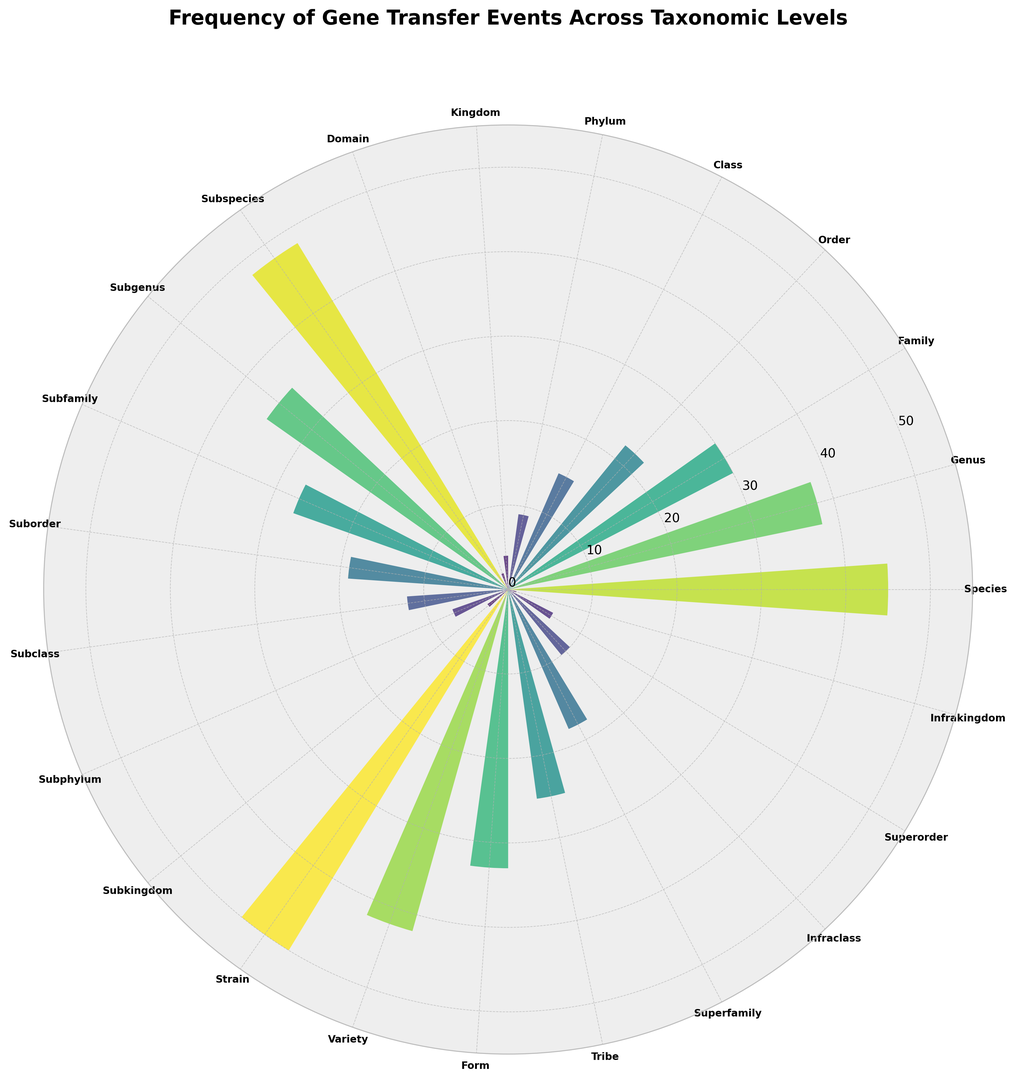Which taxonomic level has the highest frequency of gene transfer events? By examining the length of the bars, the strain level has the highest bar.
Answer: Strain Which taxonomic level has the lowest frequency of gene transfer events, and how many events are there? To find the lowest frequency, look for the shortest bar. The infrakingdom level has the shortest bar, and it shows a frequency of 1.
Answer: Infrakingdom, 1 Compare the frequency of gene transfer events between the genus and family levels. Which one is higher and by how much? The genus level has a frequency of 38, while the family level has a frequency of 30. The difference is 38 - 30 = 8.
Answer: Genus, by 8 What is the combined frequency of gene transfer events for the subclass and superorder levels? The subclass level has a frequency of 12 and the superorder has 6. Their combined frequency is 12 + 6 = 18.
Answer: 18 How many taxonomic levels have a frequency of gene transfer events greater than 20? By counting the bars with heights above 20: species, genus, subspecies, strain, variety, form, and tribe. There are 7 levels.
Answer: 7 Which has a higher frequency of gene transfer events, the subfamily or the superfamily level? By how much? The subfamily level has a frequency of 27, while the superfamily has 18. The difference is 27 - 18 = 9.
Answer: Subfamily, by 9 What is the average frequency of gene transfer events for taxonomic levels from class to kingdom? The frequencies are 15 (class), 9 (phylum), 4 (kingdom). The sum is 15 + 9 + 4 = 28, and the average is 28/3 ≈ 9.33.
Answer: 9.33 Compare the frequency of gene transfer events between subspecies and strain levels. How do they relate? The frequency for subspecies is 48 and for strain it is 50; so strain is 2 higher than subspecies.
Answer: Strain is 2 higher What is the median frequency of gene transfer events for the given taxonomic levels? Ordering the frequencies: 1, 2, 3, 4, 6, 7, 9, 10, 12, 15, 18, 19, 22, 25, 27, 30, 33, 35, 38, 42, 45, 48, 50; the middle value (median) is 22.
Answer: 22 